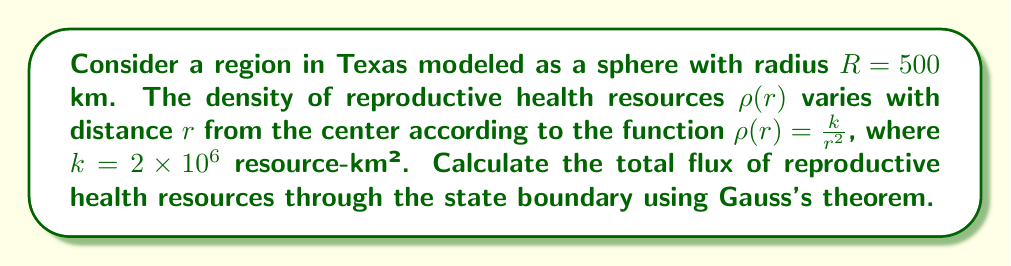Could you help me with this problem? 1) Gauss's theorem states that the flux through a closed surface is equal to the volume integral of the divergence of the vector field over the enclosed volume.

2) In this case, we have a scalar field $\rho(r)$, so we need to consider the flux of the radial vector field $\mathbf{F} = \rho(r)\hat{r}$.

3) The divergence of this field in spherical coordinates is:

   $$\nabla \cdot \mathbf{F} = \frac{1}{r^2}\frac{\partial}{\partial r}(r^2\rho(r)) = \frac{1}{r^2}\frac{\partial}{\partial r}(r^2\frac{k}{r^2}) = \frac{1}{r^2}\frac{\partial}{\partial r}(k) = 0$$

4) Since the divergence is zero, the flux through any closed surface will be the same. We can choose the surface of the sphere with radius $R$.

5) The flux is given by the surface integral:

   $$\Phi = \int_S \mathbf{F} \cdot d\mathbf{A} = \int_S \rho(R) R^2 \sin\theta d\theta d\phi$$

6) Substituting $\rho(R) = \frac{k}{R^2}$:

   $$\Phi = \int_0^{2\pi} \int_0^{\pi} \frac{k}{R^2} R^2 \sin\theta d\theta d\phi = k \int_0^{2\pi} d\phi \int_0^{\pi} \sin\theta d\theta$$

7) Evaluating the integrals:

   $$\Phi = k [2\pi][-\cos\theta]_0^{\pi} = 4\pi k$$

8) Substituting the given values:

   $$\Phi = 4\pi (2 \times 10^6) = 2.513 \times 10^7 \text{ resources}$$
Answer: $2.513 \times 10^7$ resources 